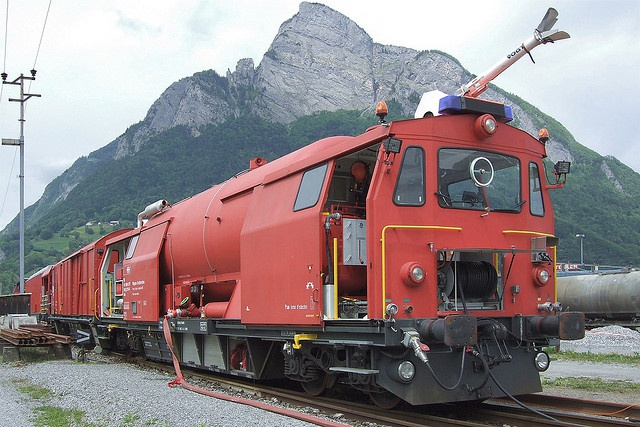Describe the objects in this image and their specific colors. I can see train in white, black, salmon, brown, and gray tones and train in white, gray, darkgray, black, and lightgray tones in this image. 